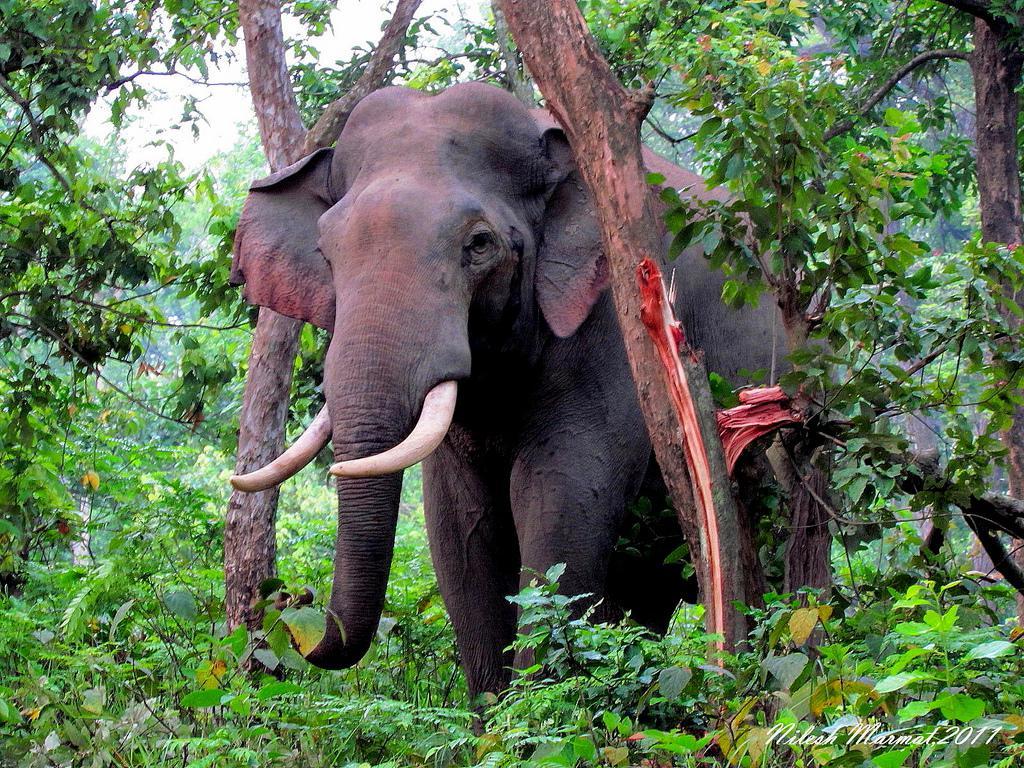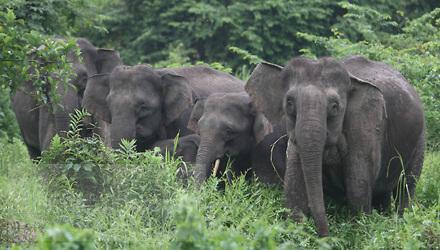The first image is the image on the left, the second image is the image on the right. For the images displayed, is the sentence "One image shows at least one elephant standing in a wet area." factually correct? Answer yes or no. No. The first image is the image on the left, the second image is the image on the right. Analyze the images presented: Is the assertion "There is one tusked animal in the grass in the image on the left." valid? Answer yes or no. Yes. The first image is the image on the left, the second image is the image on the right. Analyze the images presented: Is the assertion "An image features just one elephant, which has large tusks." valid? Answer yes or no. Yes. 